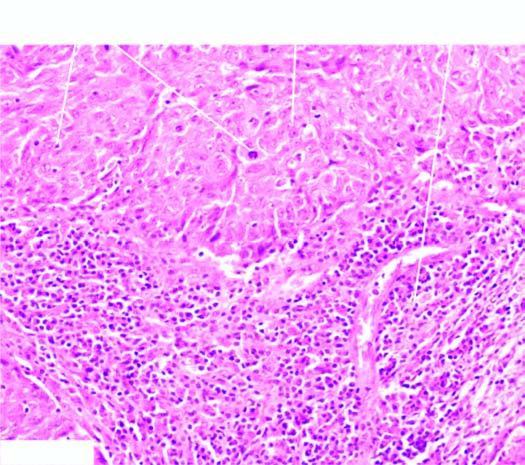how many characteristic features does microscopy show?
Answer the question using a single word or phrase. Two 